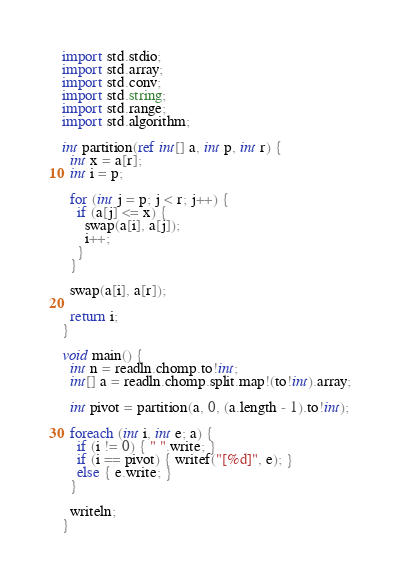<code> <loc_0><loc_0><loc_500><loc_500><_D_>import std.stdio;
import std.array;
import std.conv;
import std.string;
import std.range;
import std.algorithm;

int partition(ref int[] a, int p, int r) {
  int x = a[r];
  int i = p;

  for (int j = p; j < r; j++) {
    if (a[j] <= x) {
      swap(a[i], a[j]);
      i++;
    }
  }

  swap(a[i], a[r]);

  return i;
}

void main() {
  int n = readln.chomp.to!int;
  int[] a = readln.chomp.split.map!(to!int).array;

  int pivot = partition(a, 0, (a.length - 1).to!int);

  foreach (int i, int e; a) {
    if (i != 0) { " ".write; }
    if (i == pivot) { writef("[%d]", e); }
    else { e.write; }
  }

  writeln;
}</code> 